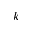Convert formula to latex. <formula><loc_0><loc_0><loc_500><loc_500>k</formula> 